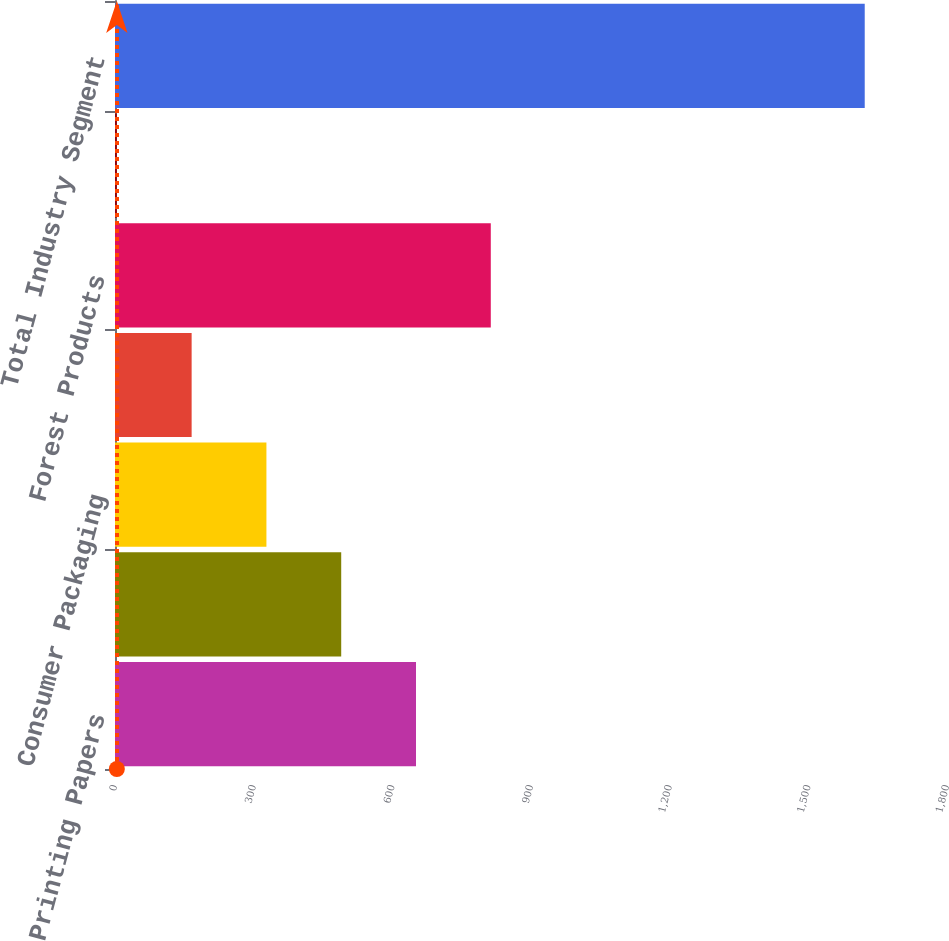Convert chart. <chart><loc_0><loc_0><loc_500><loc_500><bar_chart><fcel>Printing Papers<fcel>Industrial Packaging<fcel>Consumer Packaging<fcel>Distribution<fcel>Forest Products<fcel>Specialty Businesses and Other<fcel>Total Industry Segment<nl><fcel>651.2<fcel>489.4<fcel>327.6<fcel>165.8<fcel>813<fcel>4<fcel>1622<nl></chart> 